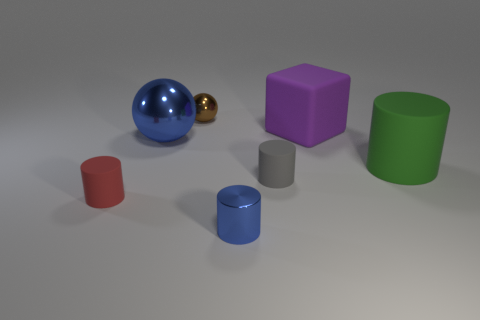Does the large ball have the same color as the tiny sphere?
Ensure brevity in your answer.  No. How many things are either tiny metallic objects behind the gray cylinder or big green matte blocks?
Make the answer very short. 1. There is another ball that is the same material as the small ball; what size is it?
Keep it short and to the point. Large. Is the number of tiny metallic things in front of the purple rubber block greater than the number of tiny brown rubber balls?
Provide a succinct answer. Yes. Do the green matte object and the small metallic object in front of the big blue metallic thing have the same shape?
Offer a very short reply. Yes. How many small things are either red rubber cylinders or metal balls?
Keep it short and to the point. 2. There is a metal ball that is the same color as the shiny cylinder; what size is it?
Your answer should be very brief. Large. What color is the metal ball that is in front of the tiny metal object left of the small blue cylinder?
Your answer should be very brief. Blue. Is the material of the small gray cylinder the same as the cylinder on the right side of the small gray cylinder?
Your answer should be very brief. Yes. What material is the tiny cylinder behind the small red thing?
Provide a succinct answer. Rubber. 